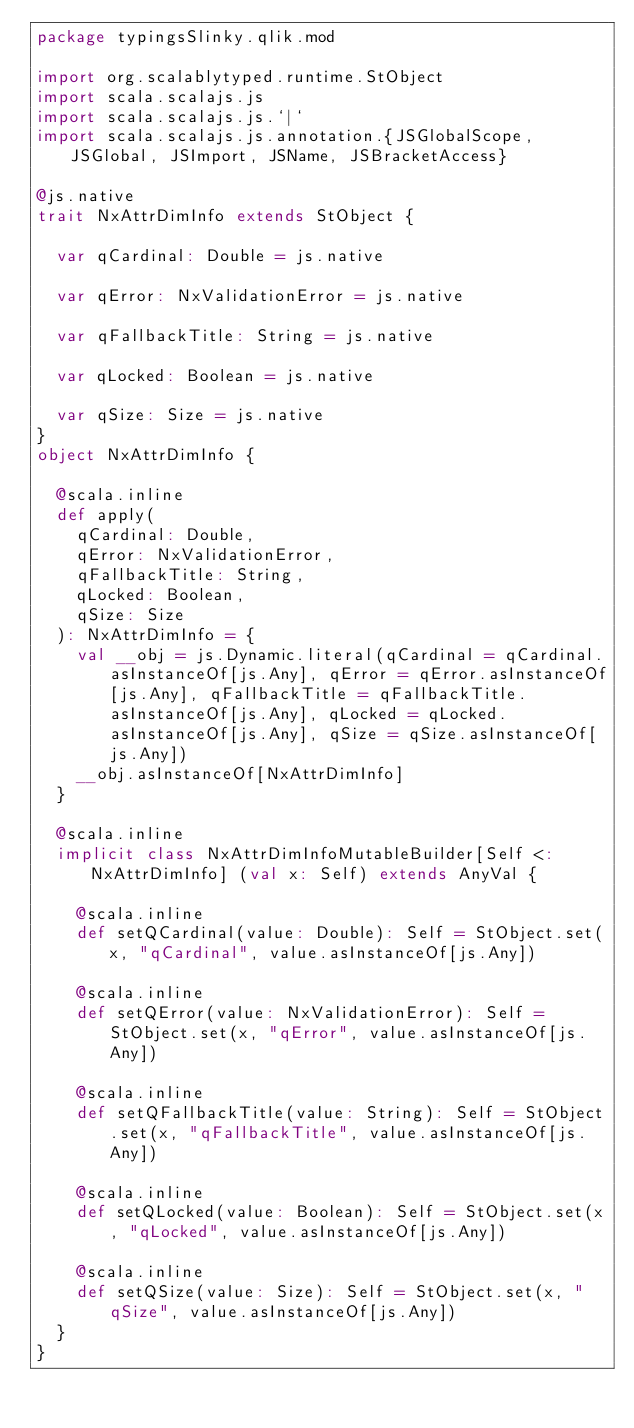Convert code to text. <code><loc_0><loc_0><loc_500><loc_500><_Scala_>package typingsSlinky.qlik.mod

import org.scalablytyped.runtime.StObject
import scala.scalajs.js
import scala.scalajs.js.`|`
import scala.scalajs.js.annotation.{JSGlobalScope, JSGlobal, JSImport, JSName, JSBracketAccess}

@js.native
trait NxAttrDimInfo extends StObject {
  
  var qCardinal: Double = js.native
  
  var qError: NxValidationError = js.native
  
  var qFallbackTitle: String = js.native
  
  var qLocked: Boolean = js.native
  
  var qSize: Size = js.native
}
object NxAttrDimInfo {
  
  @scala.inline
  def apply(
    qCardinal: Double,
    qError: NxValidationError,
    qFallbackTitle: String,
    qLocked: Boolean,
    qSize: Size
  ): NxAttrDimInfo = {
    val __obj = js.Dynamic.literal(qCardinal = qCardinal.asInstanceOf[js.Any], qError = qError.asInstanceOf[js.Any], qFallbackTitle = qFallbackTitle.asInstanceOf[js.Any], qLocked = qLocked.asInstanceOf[js.Any], qSize = qSize.asInstanceOf[js.Any])
    __obj.asInstanceOf[NxAttrDimInfo]
  }
  
  @scala.inline
  implicit class NxAttrDimInfoMutableBuilder[Self <: NxAttrDimInfo] (val x: Self) extends AnyVal {
    
    @scala.inline
    def setQCardinal(value: Double): Self = StObject.set(x, "qCardinal", value.asInstanceOf[js.Any])
    
    @scala.inline
    def setQError(value: NxValidationError): Self = StObject.set(x, "qError", value.asInstanceOf[js.Any])
    
    @scala.inline
    def setQFallbackTitle(value: String): Self = StObject.set(x, "qFallbackTitle", value.asInstanceOf[js.Any])
    
    @scala.inline
    def setQLocked(value: Boolean): Self = StObject.set(x, "qLocked", value.asInstanceOf[js.Any])
    
    @scala.inline
    def setQSize(value: Size): Self = StObject.set(x, "qSize", value.asInstanceOf[js.Any])
  }
}
</code> 